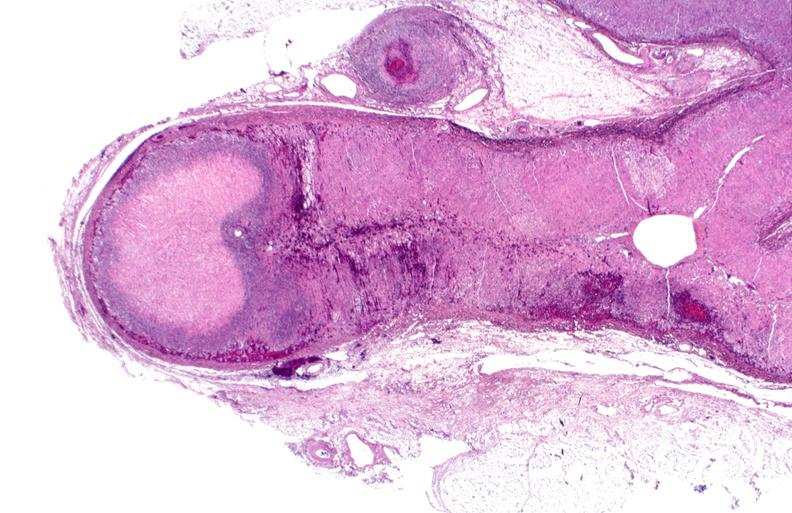where is this part in the figure?
Answer the question using a single word or phrase. Endocrine system 